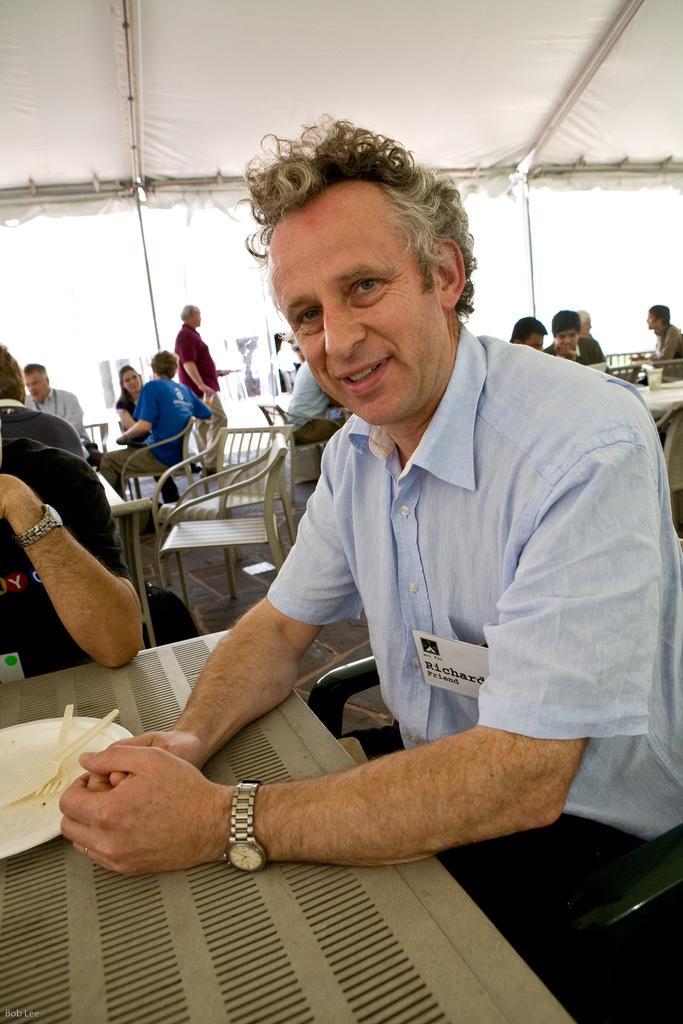In one or two sentences, can you explain what this image depicts? This image consists of a tent where there are so many people sitting under the tent. There are tables chairs, men and women in this image. There is a person sitting on the chair in the middle of the image. He has a plate in front of him on the left side it has a knife and fork. This men wore blue color shirt and black color pant. He also has a watch to his hand ,the person who is sitting beside this man to the left side wore black shirt and he also has watch to his hand. 